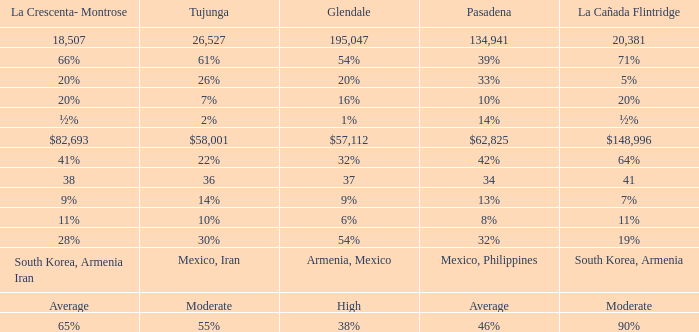What is the percentage of Glendale when Pasadena is 14%? 1%. 